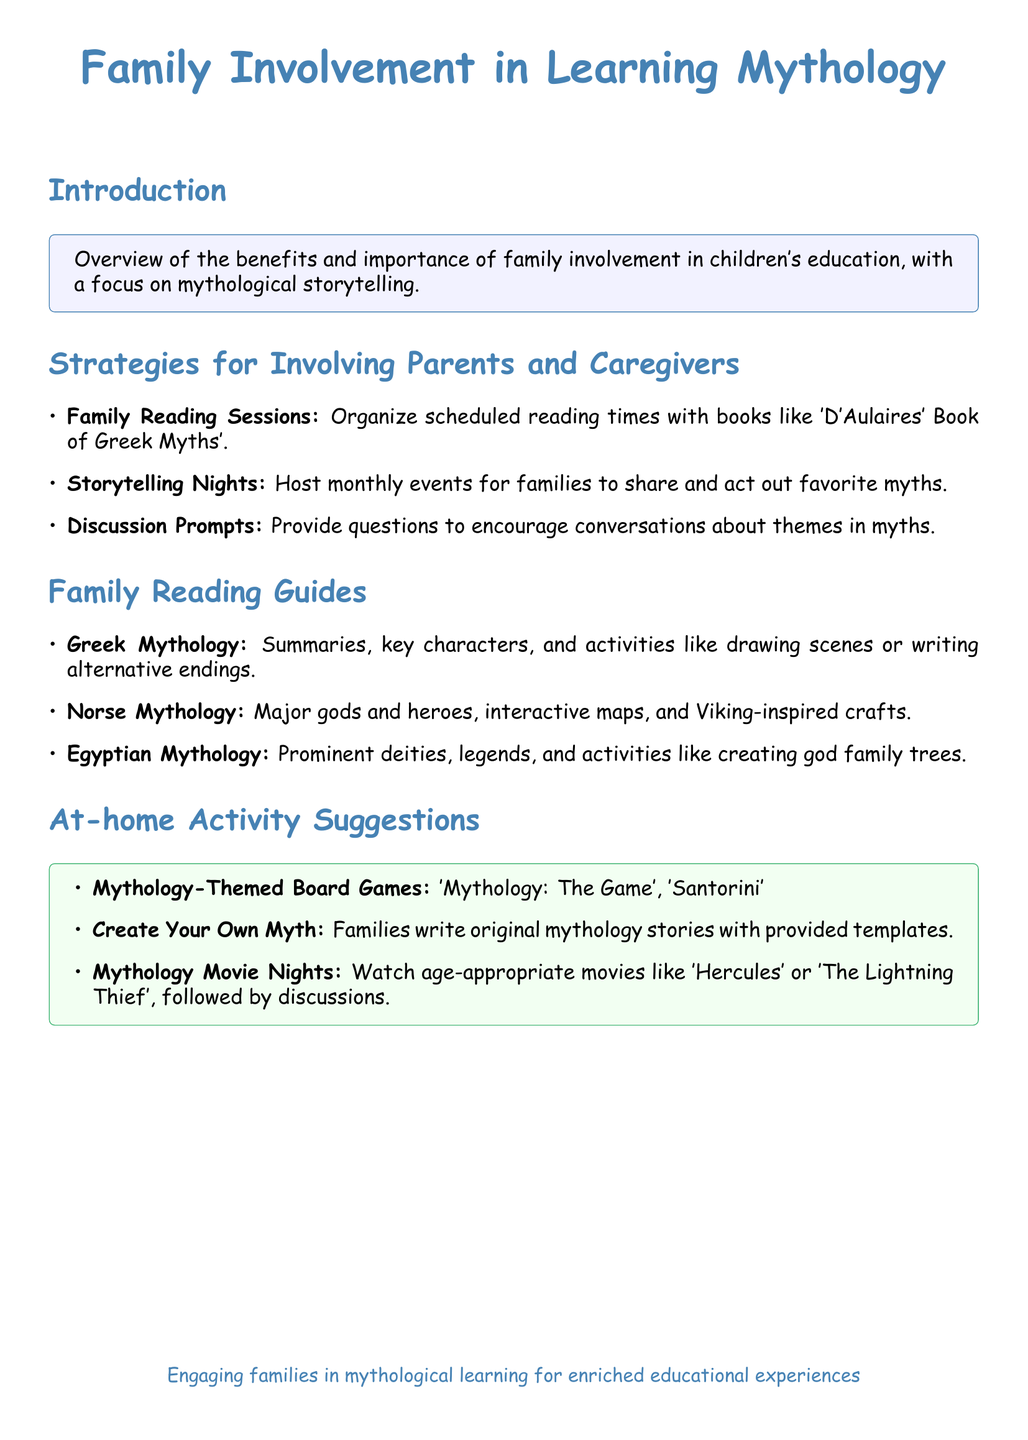What is the title of the document? The title is prominently displayed at the top of the document and is "Family Involvement in Learning Mythology."
Answer: Family Involvement in Learning Mythology What is one activity suggested for family involvement? The document lists multiple activities, one of which is "Host monthly events for families to share and act out favorite myths."
Answer: Host monthly events for families to share and act out favorite myths Which mythology includes creating god family trees as an activity? The document specifies activities under "Egyptian Mythology," which includes creating god family trees.
Answer: Egyptian Mythology What type of games are suggested for at-home activities? The document suggests playing "Mythology-Themed Board Games."
Answer: Mythology-Themed Board Games How many types of mythology are mentioned in the Family Reading Guides section? The Family Reading Guides mention three types of mythology: Greek, Norse, and Egyptian.
Answer: Three What color is used for the title of the document? The title uses the color defined as 'mythblue.'
Answer: mythblue What is the purpose of Discussion Prompts mentioned in the Strategies section? The purpose of Discussion Prompts is to encourage conversations about themes in myths.
Answer: Encourage conversations about themes in myths 